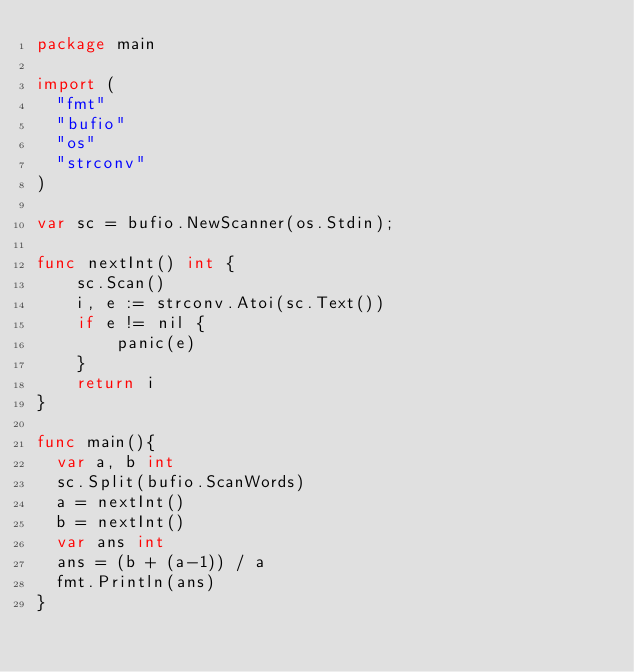Convert code to text. <code><loc_0><loc_0><loc_500><loc_500><_Go_>package main

import (
	"fmt"
	"bufio"
	"os"
	"strconv"
)

var sc = bufio.NewScanner(os.Stdin);

func nextInt() int {
    sc.Scan()
    i, e := strconv.Atoi(sc.Text())
    if e != nil {
        panic(e)
    }
    return i
}

func main(){
	var a, b int
	sc.Split(bufio.ScanWords)
	a = nextInt()
	b = nextInt()
	var ans int
	ans = (b + (a-1)) / a
	fmt.Println(ans)
}</code> 